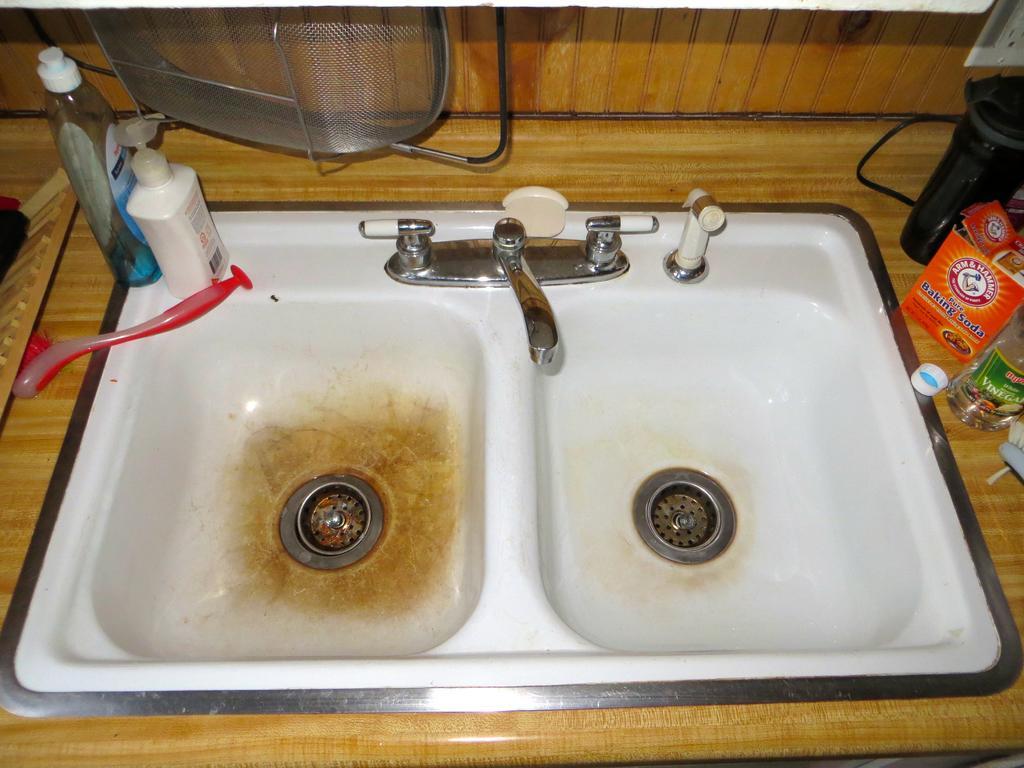Please provide a concise description of this image. In this image we can see sink, taps, daily essentials and a switch board. 